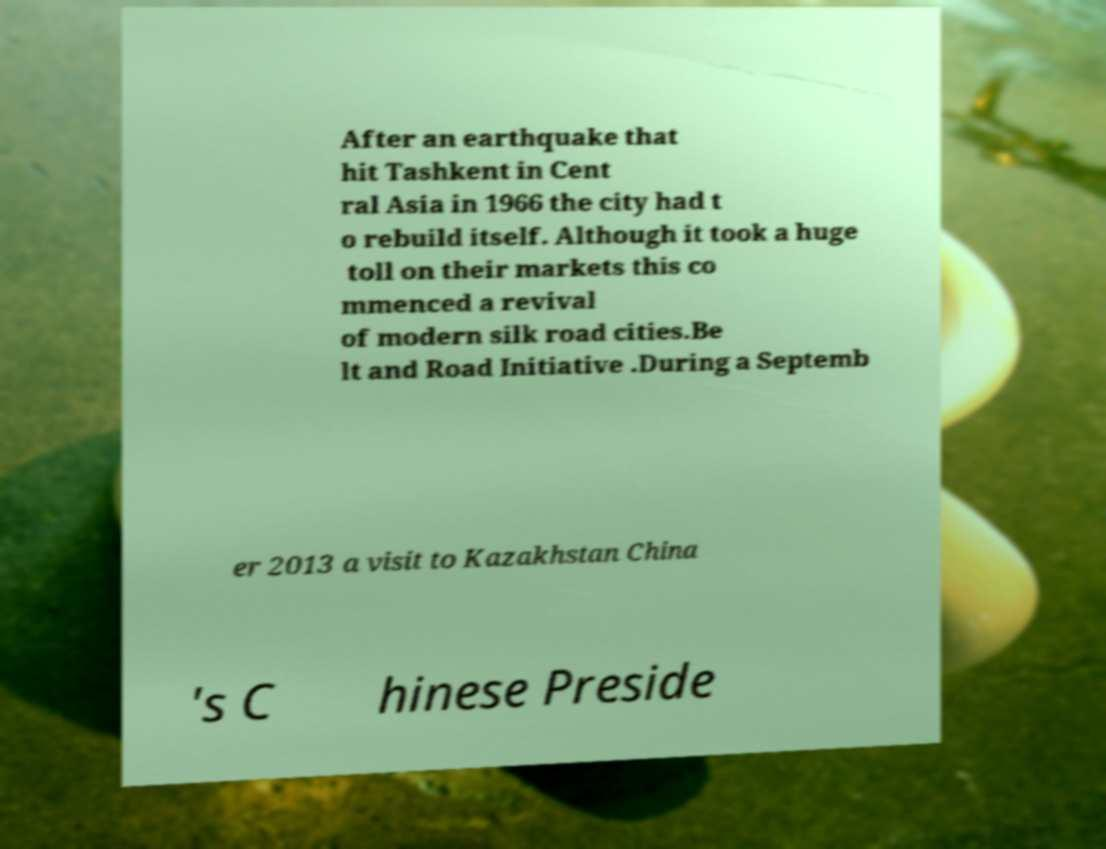I need the written content from this picture converted into text. Can you do that? After an earthquake that hit Tashkent in Cent ral Asia in 1966 the city had t o rebuild itself. Although it took a huge toll on their markets this co mmenced a revival of modern silk road cities.Be lt and Road Initiative .During a Septemb er 2013 a visit to Kazakhstan China 's C hinese Preside 